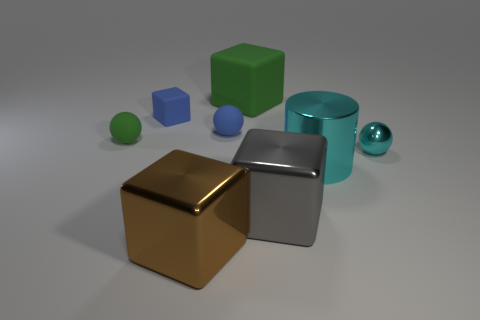Add 1 tiny metal spheres. How many objects exist? 9 Subtract all cylinders. How many objects are left? 7 Add 6 large green matte cylinders. How many large green matte cylinders exist? 6 Subtract 0 cyan blocks. How many objects are left? 8 Subtract all cubes. Subtract all matte cubes. How many objects are left? 2 Add 1 shiny spheres. How many shiny spheres are left? 2 